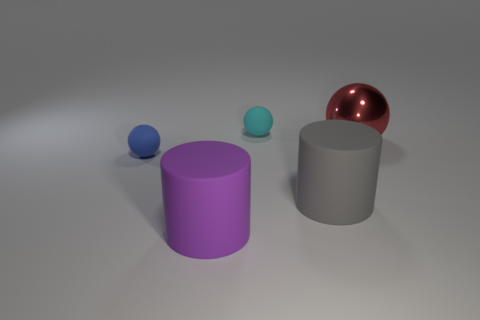Add 3 big purple cylinders. How many objects exist? 8 Subtract all cylinders. How many objects are left? 3 Subtract 1 gray cylinders. How many objects are left? 4 Subtract all tiny cyan objects. Subtract all metallic things. How many objects are left? 3 Add 2 metal balls. How many metal balls are left? 3 Add 2 big gray rubber cylinders. How many big gray rubber cylinders exist? 3 